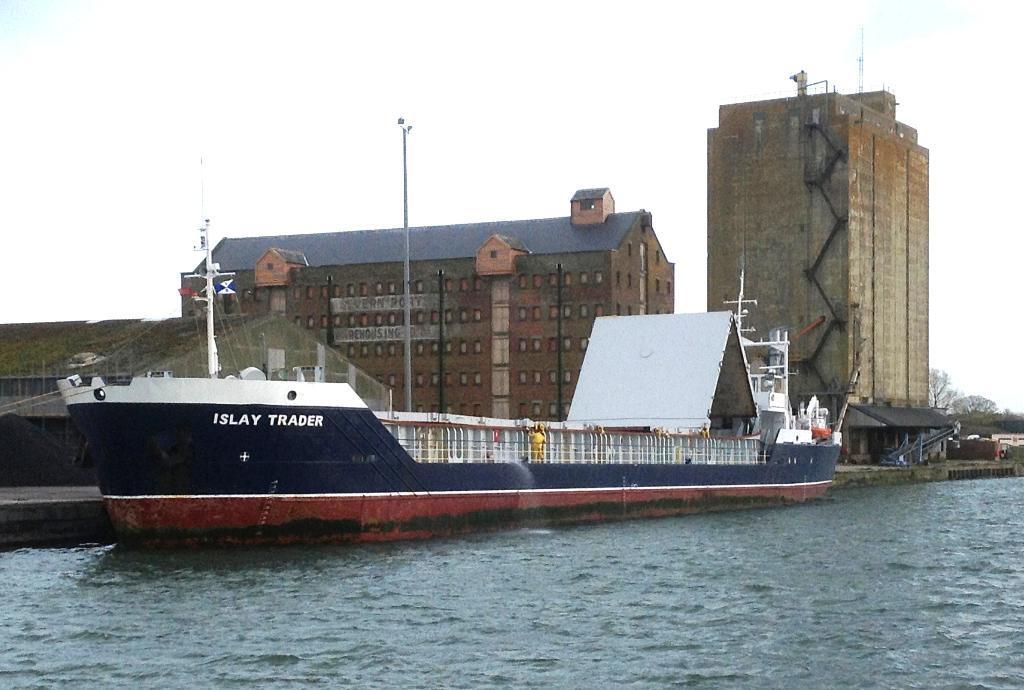Please provide a concise description of this image. In this image I can see in the middle there is a ship in the water and there are buildings, on the right side there are trees. At the top there is the sky. 